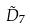Convert formula to latex. <formula><loc_0><loc_0><loc_500><loc_500>\tilde { D } _ { 7 }</formula> 